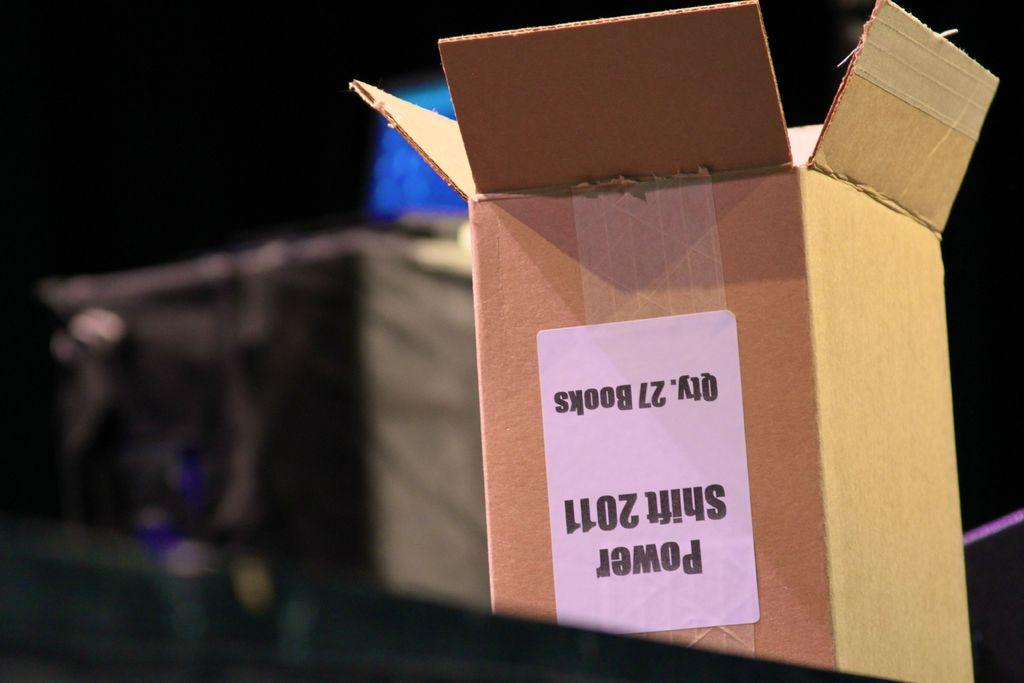Provide a one-sentence caption for the provided image. An upside down box the originally contained 27 copies of Power Shift 2011. 